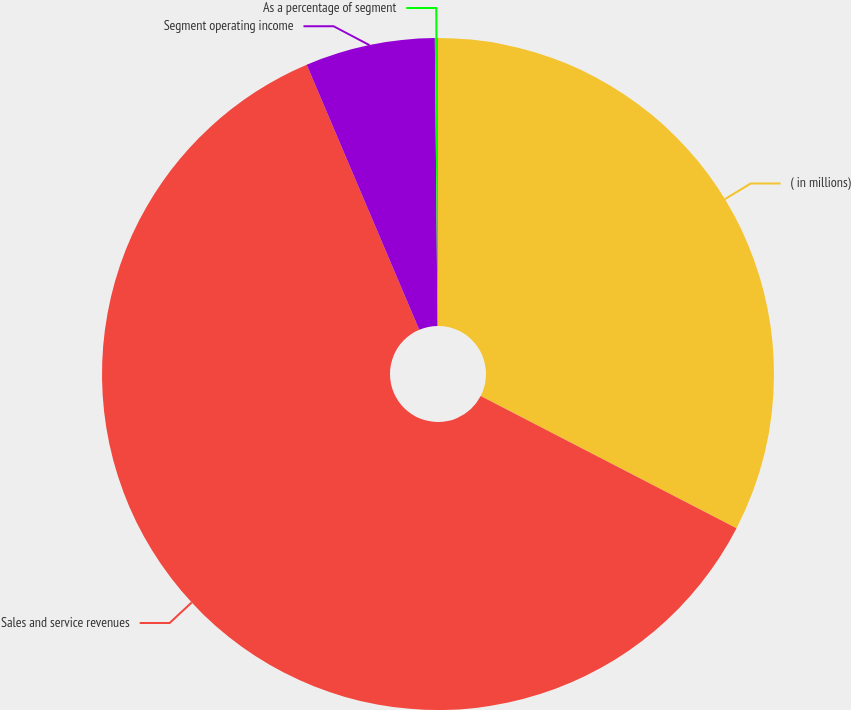<chart> <loc_0><loc_0><loc_500><loc_500><pie_chart><fcel>( in millions)<fcel>Sales and service revenues<fcel>Segment operating income<fcel>As a percentage of segment<nl><fcel>32.59%<fcel>61.03%<fcel>6.24%<fcel>0.15%<nl></chart> 